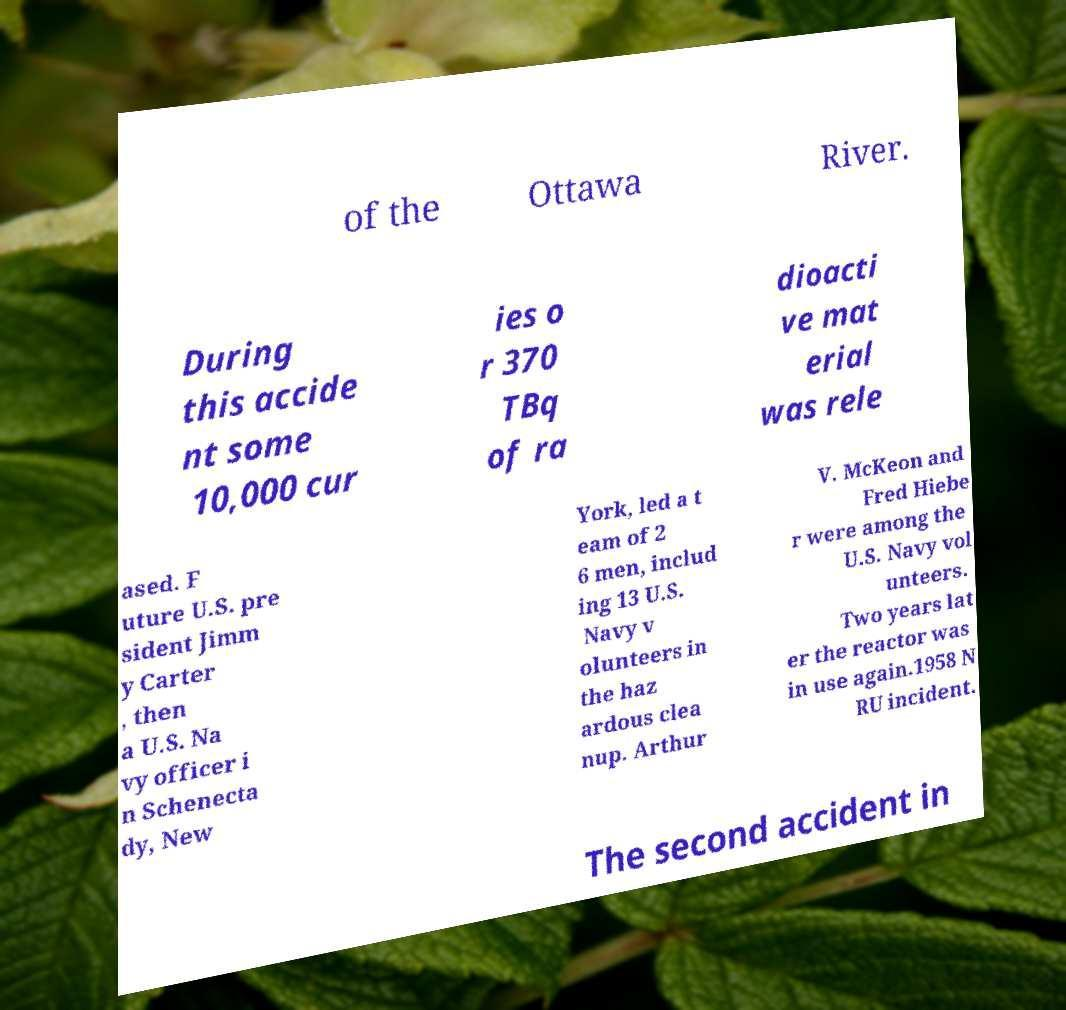There's text embedded in this image that I need extracted. Can you transcribe it verbatim? of the Ottawa River. During this accide nt some 10,000 cur ies o r 370 TBq of ra dioacti ve mat erial was rele ased. F uture U.S. pre sident Jimm y Carter , then a U.S. Na vy officer i n Schenecta dy, New York, led a t eam of 2 6 men, includ ing 13 U.S. Navy v olunteers in the haz ardous clea nup. Arthur V. McKeon and Fred Hiebe r were among the U.S. Navy vol unteers. Two years lat er the reactor was in use again.1958 N RU incident. The second accident in 